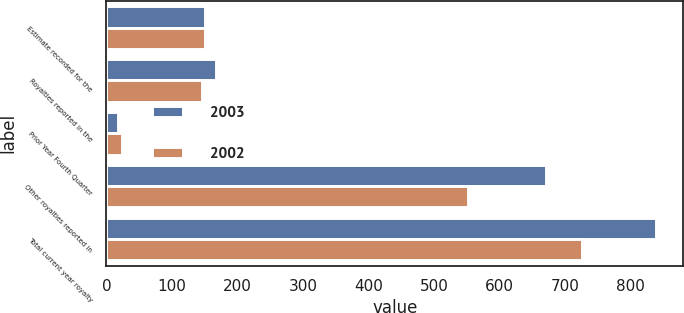Convert chart to OTSL. <chart><loc_0><loc_0><loc_500><loc_500><stacked_bar_chart><ecel><fcel>Estimate recorded for the<fcel>Royalties reported in the<fcel>Prior Year Fourth Quarter<fcel>Other royalties reported in<fcel>Total current year royalty<nl><fcel>2003<fcel>151<fcel>167<fcel>17<fcel>670<fcel>838<nl><fcel>2002<fcel>150<fcel>146<fcel>24<fcel>551<fcel>725<nl></chart> 